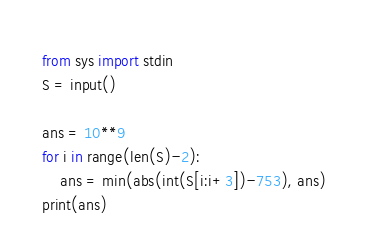<code> <loc_0><loc_0><loc_500><loc_500><_Python_>from sys import stdin
S = input()

ans = 10**9
for i in range(len(S)-2):
    ans = min(abs(int(S[i:i+3])-753), ans)
print(ans)
</code> 